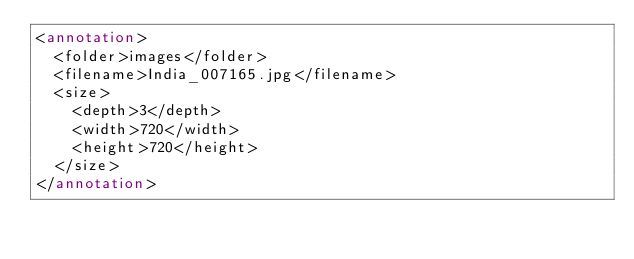<code> <loc_0><loc_0><loc_500><loc_500><_XML_><annotation>
  <folder>images</folder>
  <filename>India_007165.jpg</filename>
  <size>
    <depth>3</depth>
    <width>720</width>
    <height>720</height>
  </size>
</annotation></code> 